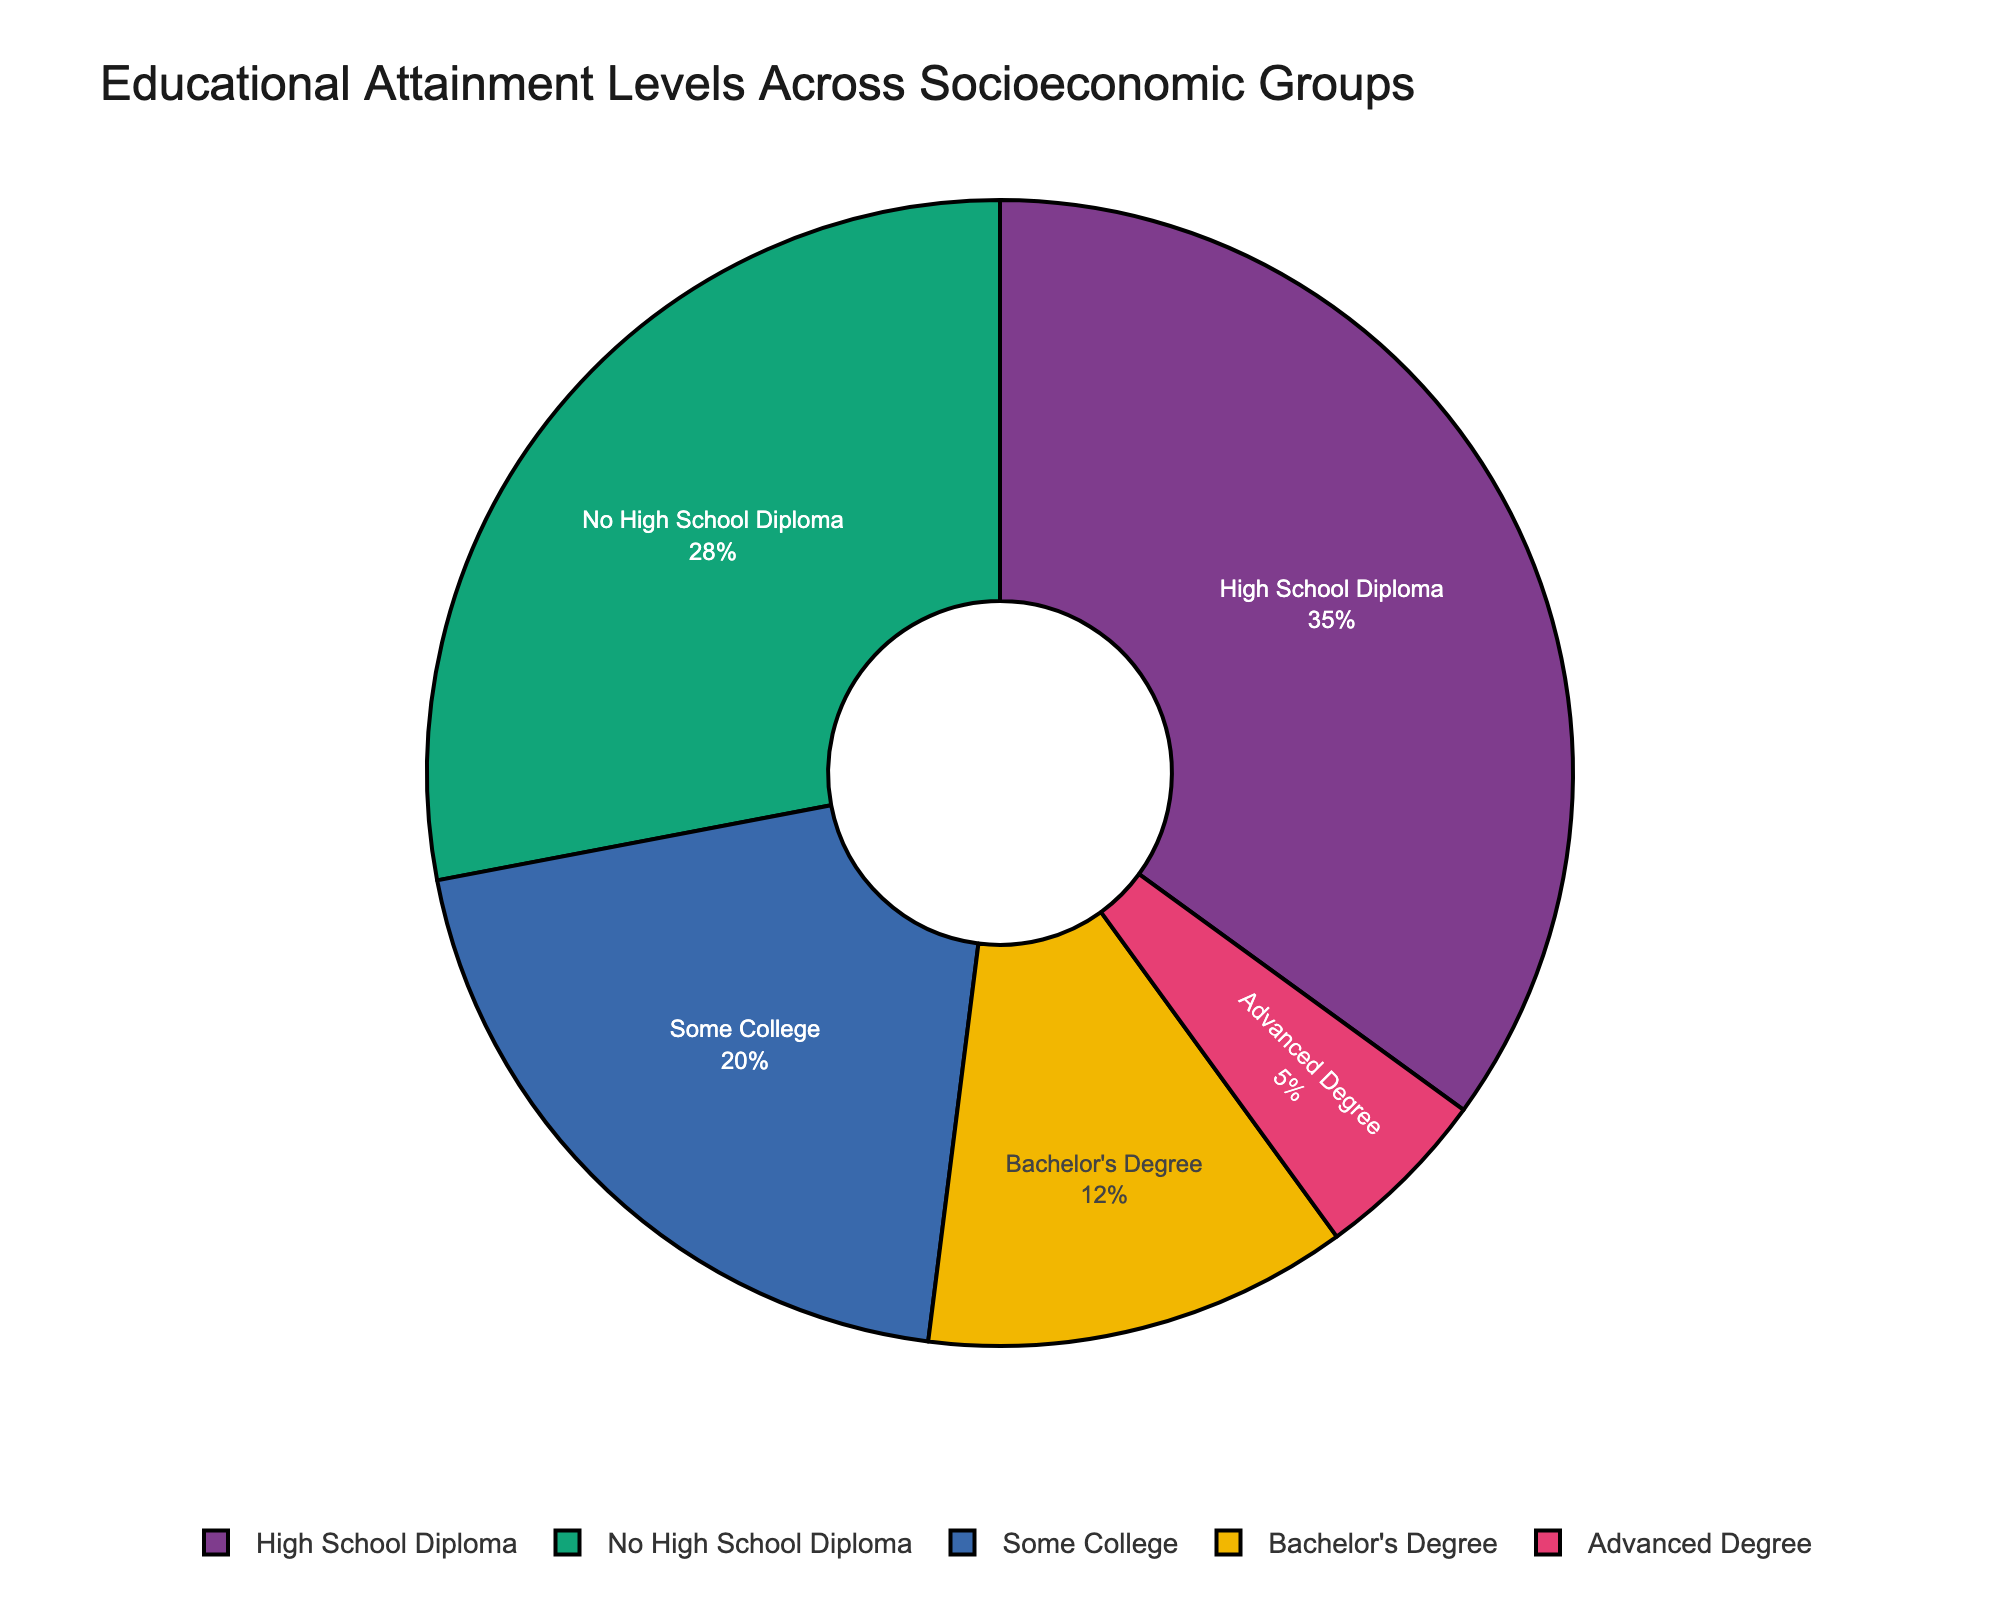What percentage of the population has at least a Bachelor's degree? To find the percentage of the population with at least a Bachelor's degree, add the percentages of those with Bachelor's Degree (12%) and Advanced Degree (5%): 12% + 5% = 17%
Answer: 17% Which educational attainment level has the largest percentage? Look at the slices of the pie chart to see which educational attainment level occupies the largest area, marked by "High School Diploma" at 35%.
Answer: High School Diploma What is the difference in percentage between those with a High School Diploma and those with Some College education? Subtract the percentage of Some College education (20%) from the percentage of High School Diploma (35%): 35% - 20% = 15%
Answer: 15% Which group has a lower percentage: those with an Advanced Degree or those with No High School Diploma? Compare the percentages of the slices labeled "Advanced Degree" (5%) and "No High School Diploma" (28%). The group with the smaller percentage is "Advanced Degree."
Answer: Advanced Degree Is the cumulative percentage of people with less than a Bachelor's Degree higher than those with a Bachelor's Degree or higher? Add the percentages of No High School Diploma (28%), High School Diploma (35%), and Some College (20%): 28% + 35% + 20% = 83%. Compare it with the cumulative percentage of Bachelor's Degree (12%) and Advanced Degree (5%): 12% + 5% = 17%. 83% > 17%.
Answer: Yes What fraction of the entire population holds an Advanced Degree? The slice representing an Advanced Degree shows 5%, which is equal to 5/100 or 1/20 when converted to a fraction.
Answer: 1/20 How much larger is the percentage of people with a High School Diploma compared to the percentage of those with a Bachelor's Degree? Find the absolute difference between the percentage of High School Diploma (35%) and Bachelor's Degree (12%): 35% - 12% = 23%.
Answer: 23% Is more than half of the population at least completing high school (High School Diploma or higher)? Add up the percentages of those with a High School Diploma (35%), Some College (20%), Bachelor's Degree (12%), and Advanced Degree (5%): 35% + 20% + 12% + 5% = 72%. Since 72% > 50%, more than half have at least a High School Diploma.
Answer: Yes What is the most common educational attainment level among socioeconomic groups? The largest slice of the pie chart, representing the most common educational attainment level, is High School Diploma, which is 35%.
Answer: High School Diploma 